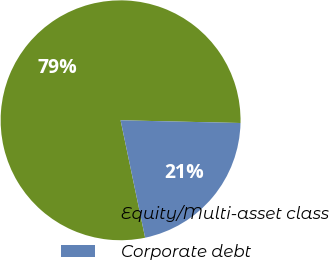Convert chart to OTSL. <chart><loc_0><loc_0><loc_500><loc_500><pie_chart><fcel>Equity/Multi-asset class<fcel>Corporate debt<nl><fcel>78.64%<fcel>21.36%<nl></chart> 